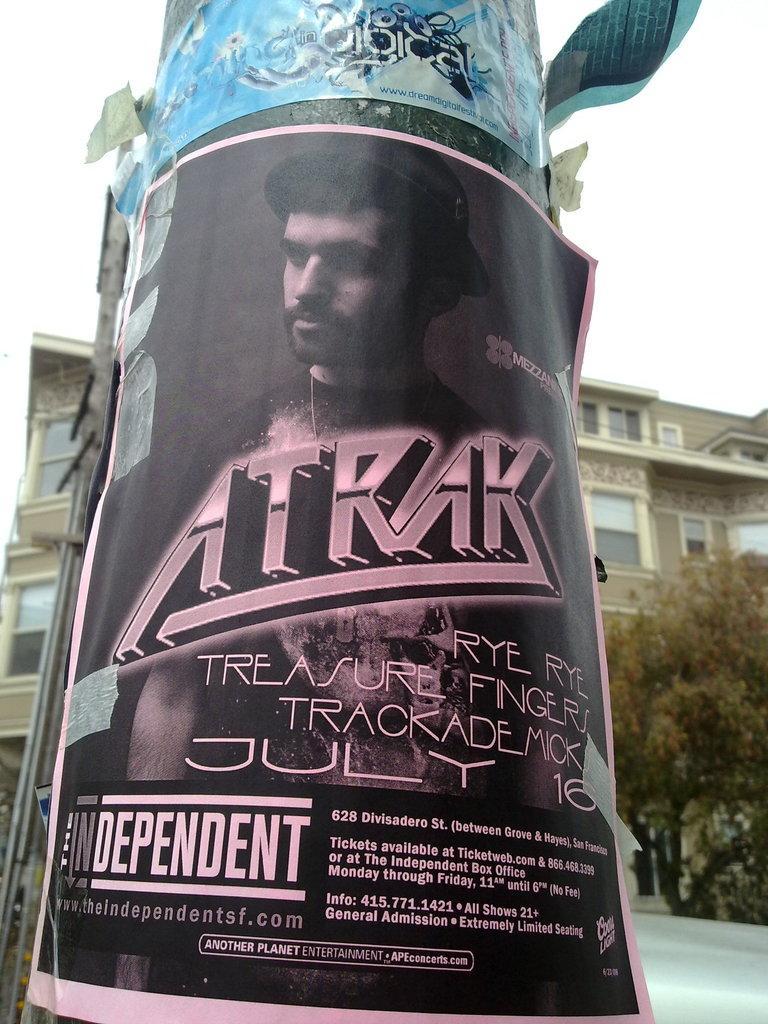Could you give a brief overview of what you see in this image? In this picture we can see there are posters on the pole. Behind the pole, there is a building, tree and the sky. On the left side of the image, it looks like another pole. 